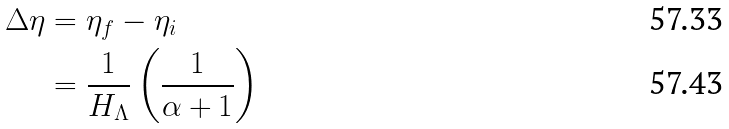<formula> <loc_0><loc_0><loc_500><loc_500>\Delta \eta & = \eta _ { f } - \eta _ { i } & \\ & = \frac { 1 } { H _ { \Lambda } } \left ( \frac { 1 } { \alpha + 1 } \right ) &</formula> 